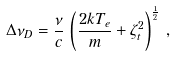Convert formula to latex. <formula><loc_0><loc_0><loc_500><loc_500>\Delta \nu _ { D } = \frac { \nu } { c } \, \left ( \frac { 2 k T _ { e } } { m } + \zeta _ { t } ^ { 2 } \right ) ^ { \frac { 1 } { 2 } } \, ,</formula> 